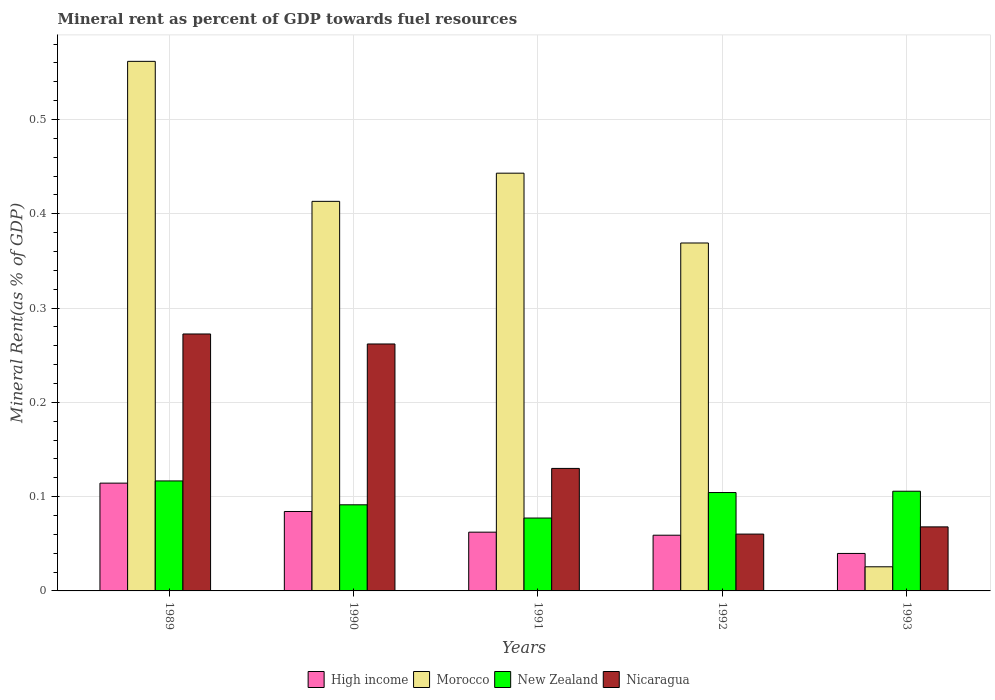How many different coloured bars are there?
Offer a terse response. 4. Are the number of bars per tick equal to the number of legend labels?
Give a very brief answer. Yes. Are the number of bars on each tick of the X-axis equal?
Make the answer very short. Yes. How many bars are there on the 2nd tick from the left?
Offer a terse response. 4. How many bars are there on the 2nd tick from the right?
Give a very brief answer. 4. In how many cases, is the number of bars for a given year not equal to the number of legend labels?
Make the answer very short. 0. What is the mineral rent in Nicaragua in 1989?
Your response must be concise. 0.27. Across all years, what is the maximum mineral rent in High income?
Make the answer very short. 0.11. Across all years, what is the minimum mineral rent in High income?
Make the answer very short. 0.04. In which year was the mineral rent in Nicaragua maximum?
Ensure brevity in your answer.  1989. What is the total mineral rent in High income in the graph?
Provide a short and direct response. 0.36. What is the difference between the mineral rent in New Zealand in 1990 and that in 1992?
Make the answer very short. -0.01. What is the difference between the mineral rent in New Zealand in 1989 and the mineral rent in High income in 1990?
Offer a terse response. 0.03. What is the average mineral rent in Morocco per year?
Keep it short and to the point. 0.36. In the year 1989, what is the difference between the mineral rent in Morocco and mineral rent in Nicaragua?
Make the answer very short. 0.29. What is the ratio of the mineral rent in Nicaragua in 1989 to that in 1991?
Provide a succinct answer. 2.1. What is the difference between the highest and the second highest mineral rent in Nicaragua?
Ensure brevity in your answer.  0.01. What is the difference between the highest and the lowest mineral rent in New Zealand?
Provide a short and direct response. 0.04. Is the sum of the mineral rent in New Zealand in 1990 and 1991 greater than the maximum mineral rent in High income across all years?
Keep it short and to the point. Yes. What does the 3rd bar from the left in 1992 represents?
Offer a very short reply. New Zealand. What does the 3rd bar from the right in 1990 represents?
Offer a very short reply. Morocco. Is it the case that in every year, the sum of the mineral rent in High income and mineral rent in Nicaragua is greater than the mineral rent in Morocco?
Ensure brevity in your answer.  No. Are all the bars in the graph horizontal?
Ensure brevity in your answer.  No. Does the graph contain grids?
Your answer should be very brief. Yes. Where does the legend appear in the graph?
Keep it short and to the point. Bottom center. How are the legend labels stacked?
Give a very brief answer. Horizontal. What is the title of the graph?
Ensure brevity in your answer.  Mineral rent as percent of GDP towards fuel resources. What is the label or title of the X-axis?
Keep it short and to the point. Years. What is the label or title of the Y-axis?
Your response must be concise. Mineral Rent(as % of GDP). What is the Mineral Rent(as % of GDP) of High income in 1989?
Keep it short and to the point. 0.11. What is the Mineral Rent(as % of GDP) in Morocco in 1989?
Ensure brevity in your answer.  0.56. What is the Mineral Rent(as % of GDP) of New Zealand in 1989?
Your answer should be very brief. 0.12. What is the Mineral Rent(as % of GDP) in Nicaragua in 1989?
Provide a succinct answer. 0.27. What is the Mineral Rent(as % of GDP) of High income in 1990?
Provide a succinct answer. 0.08. What is the Mineral Rent(as % of GDP) of Morocco in 1990?
Provide a succinct answer. 0.41. What is the Mineral Rent(as % of GDP) of New Zealand in 1990?
Give a very brief answer. 0.09. What is the Mineral Rent(as % of GDP) of Nicaragua in 1990?
Your answer should be compact. 0.26. What is the Mineral Rent(as % of GDP) in High income in 1991?
Keep it short and to the point. 0.06. What is the Mineral Rent(as % of GDP) in Morocco in 1991?
Your answer should be very brief. 0.44. What is the Mineral Rent(as % of GDP) of New Zealand in 1991?
Your response must be concise. 0.08. What is the Mineral Rent(as % of GDP) of Nicaragua in 1991?
Make the answer very short. 0.13. What is the Mineral Rent(as % of GDP) in High income in 1992?
Offer a terse response. 0.06. What is the Mineral Rent(as % of GDP) in Morocco in 1992?
Keep it short and to the point. 0.37. What is the Mineral Rent(as % of GDP) of New Zealand in 1992?
Give a very brief answer. 0.1. What is the Mineral Rent(as % of GDP) of Nicaragua in 1992?
Keep it short and to the point. 0.06. What is the Mineral Rent(as % of GDP) of High income in 1993?
Provide a succinct answer. 0.04. What is the Mineral Rent(as % of GDP) in Morocco in 1993?
Give a very brief answer. 0.03. What is the Mineral Rent(as % of GDP) of New Zealand in 1993?
Keep it short and to the point. 0.11. What is the Mineral Rent(as % of GDP) of Nicaragua in 1993?
Give a very brief answer. 0.07. Across all years, what is the maximum Mineral Rent(as % of GDP) of High income?
Ensure brevity in your answer.  0.11. Across all years, what is the maximum Mineral Rent(as % of GDP) in Morocco?
Your response must be concise. 0.56. Across all years, what is the maximum Mineral Rent(as % of GDP) of New Zealand?
Your response must be concise. 0.12. Across all years, what is the maximum Mineral Rent(as % of GDP) in Nicaragua?
Offer a terse response. 0.27. Across all years, what is the minimum Mineral Rent(as % of GDP) of High income?
Make the answer very short. 0.04. Across all years, what is the minimum Mineral Rent(as % of GDP) in Morocco?
Offer a very short reply. 0.03. Across all years, what is the minimum Mineral Rent(as % of GDP) of New Zealand?
Make the answer very short. 0.08. Across all years, what is the minimum Mineral Rent(as % of GDP) in Nicaragua?
Offer a terse response. 0.06. What is the total Mineral Rent(as % of GDP) in High income in the graph?
Your answer should be very brief. 0.36. What is the total Mineral Rent(as % of GDP) in Morocco in the graph?
Keep it short and to the point. 1.81. What is the total Mineral Rent(as % of GDP) of New Zealand in the graph?
Offer a very short reply. 0.5. What is the total Mineral Rent(as % of GDP) of Nicaragua in the graph?
Give a very brief answer. 0.79. What is the difference between the Mineral Rent(as % of GDP) of High income in 1989 and that in 1990?
Your response must be concise. 0.03. What is the difference between the Mineral Rent(as % of GDP) of Morocco in 1989 and that in 1990?
Provide a short and direct response. 0.15. What is the difference between the Mineral Rent(as % of GDP) in New Zealand in 1989 and that in 1990?
Give a very brief answer. 0.03. What is the difference between the Mineral Rent(as % of GDP) of Nicaragua in 1989 and that in 1990?
Give a very brief answer. 0.01. What is the difference between the Mineral Rent(as % of GDP) in High income in 1989 and that in 1991?
Provide a short and direct response. 0.05. What is the difference between the Mineral Rent(as % of GDP) in Morocco in 1989 and that in 1991?
Ensure brevity in your answer.  0.12. What is the difference between the Mineral Rent(as % of GDP) of New Zealand in 1989 and that in 1991?
Your response must be concise. 0.04. What is the difference between the Mineral Rent(as % of GDP) of Nicaragua in 1989 and that in 1991?
Keep it short and to the point. 0.14. What is the difference between the Mineral Rent(as % of GDP) in High income in 1989 and that in 1992?
Ensure brevity in your answer.  0.06. What is the difference between the Mineral Rent(as % of GDP) in Morocco in 1989 and that in 1992?
Your response must be concise. 0.19. What is the difference between the Mineral Rent(as % of GDP) in New Zealand in 1989 and that in 1992?
Offer a terse response. 0.01. What is the difference between the Mineral Rent(as % of GDP) in Nicaragua in 1989 and that in 1992?
Provide a short and direct response. 0.21. What is the difference between the Mineral Rent(as % of GDP) in High income in 1989 and that in 1993?
Ensure brevity in your answer.  0.07. What is the difference between the Mineral Rent(as % of GDP) in Morocco in 1989 and that in 1993?
Offer a terse response. 0.54. What is the difference between the Mineral Rent(as % of GDP) in New Zealand in 1989 and that in 1993?
Your answer should be very brief. 0.01. What is the difference between the Mineral Rent(as % of GDP) in Nicaragua in 1989 and that in 1993?
Provide a succinct answer. 0.2. What is the difference between the Mineral Rent(as % of GDP) in High income in 1990 and that in 1991?
Give a very brief answer. 0.02. What is the difference between the Mineral Rent(as % of GDP) of Morocco in 1990 and that in 1991?
Provide a succinct answer. -0.03. What is the difference between the Mineral Rent(as % of GDP) of New Zealand in 1990 and that in 1991?
Your answer should be compact. 0.01. What is the difference between the Mineral Rent(as % of GDP) of Nicaragua in 1990 and that in 1991?
Keep it short and to the point. 0.13. What is the difference between the Mineral Rent(as % of GDP) of High income in 1990 and that in 1992?
Offer a terse response. 0.03. What is the difference between the Mineral Rent(as % of GDP) in Morocco in 1990 and that in 1992?
Make the answer very short. 0.04. What is the difference between the Mineral Rent(as % of GDP) in New Zealand in 1990 and that in 1992?
Ensure brevity in your answer.  -0.01. What is the difference between the Mineral Rent(as % of GDP) of Nicaragua in 1990 and that in 1992?
Keep it short and to the point. 0.2. What is the difference between the Mineral Rent(as % of GDP) in High income in 1990 and that in 1993?
Make the answer very short. 0.04. What is the difference between the Mineral Rent(as % of GDP) in Morocco in 1990 and that in 1993?
Provide a succinct answer. 0.39. What is the difference between the Mineral Rent(as % of GDP) in New Zealand in 1990 and that in 1993?
Offer a terse response. -0.01. What is the difference between the Mineral Rent(as % of GDP) in Nicaragua in 1990 and that in 1993?
Your response must be concise. 0.19. What is the difference between the Mineral Rent(as % of GDP) of High income in 1991 and that in 1992?
Offer a terse response. 0. What is the difference between the Mineral Rent(as % of GDP) in Morocco in 1991 and that in 1992?
Give a very brief answer. 0.07. What is the difference between the Mineral Rent(as % of GDP) in New Zealand in 1991 and that in 1992?
Your response must be concise. -0.03. What is the difference between the Mineral Rent(as % of GDP) in Nicaragua in 1991 and that in 1992?
Give a very brief answer. 0.07. What is the difference between the Mineral Rent(as % of GDP) in High income in 1991 and that in 1993?
Give a very brief answer. 0.02. What is the difference between the Mineral Rent(as % of GDP) in Morocco in 1991 and that in 1993?
Ensure brevity in your answer.  0.42. What is the difference between the Mineral Rent(as % of GDP) in New Zealand in 1991 and that in 1993?
Provide a short and direct response. -0.03. What is the difference between the Mineral Rent(as % of GDP) of Nicaragua in 1991 and that in 1993?
Offer a terse response. 0.06. What is the difference between the Mineral Rent(as % of GDP) in High income in 1992 and that in 1993?
Provide a short and direct response. 0.02. What is the difference between the Mineral Rent(as % of GDP) in Morocco in 1992 and that in 1993?
Your answer should be compact. 0.34. What is the difference between the Mineral Rent(as % of GDP) in New Zealand in 1992 and that in 1993?
Give a very brief answer. -0. What is the difference between the Mineral Rent(as % of GDP) of Nicaragua in 1992 and that in 1993?
Provide a succinct answer. -0.01. What is the difference between the Mineral Rent(as % of GDP) in High income in 1989 and the Mineral Rent(as % of GDP) in Morocco in 1990?
Offer a very short reply. -0.3. What is the difference between the Mineral Rent(as % of GDP) in High income in 1989 and the Mineral Rent(as % of GDP) in New Zealand in 1990?
Your answer should be compact. 0.02. What is the difference between the Mineral Rent(as % of GDP) in High income in 1989 and the Mineral Rent(as % of GDP) in Nicaragua in 1990?
Your answer should be very brief. -0.15. What is the difference between the Mineral Rent(as % of GDP) of Morocco in 1989 and the Mineral Rent(as % of GDP) of New Zealand in 1990?
Your answer should be compact. 0.47. What is the difference between the Mineral Rent(as % of GDP) of Morocco in 1989 and the Mineral Rent(as % of GDP) of Nicaragua in 1990?
Offer a terse response. 0.3. What is the difference between the Mineral Rent(as % of GDP) of New Zealand in 1989 and the Mineral Rent(as % of GDP) of Nicaragua in 1990?
Give a very brief answer. -0.15. What is the difference between the Mineral Rent(as % of GDP) of High income in 1989 and the Mineral Rent(as % of GDP) of Morocco in 1991?
Offer a very short reply. -0.33. What is the difference between the Mineral Rent(as % of GDP) of High income in 1989 and the Mineral Rent(as % of GDP) of New Zealand in 1991?
Provide a succinct answer. 0.04. What is the difference between the Mineral Rent(as % of GDP) of High income in 1989 and the Mineral Rent(as % of GDP) of Nicaragua in 1991?
Offer a very short reply. -0.02. What is the difference between the Mineral Rent(as % of GDP) in Morocco in 1989 and the Mineral Rent(as % of GDP) in New Zealand in 1991?
Offer a terse response. 0.48. What is the difference between the Mineral Rent(as % of GDP) in Morocco in 1989 and the Mineral Rent(as % of GDP) in Nicaragua in 1991?
Make the answer very short. 0.43. What is the difference between the Mineral Rent(as % of GDP) of New Zealand in 1989 and the Mineral Rent(as % of GDP) of Nicaragua in 1991?
Your answer should be compact. -0.01. What is the difference between the Mineral Rent(as % of GDP) in High income in 1989 and the Mineral Rent(as % of GDP) in Morocco in 1992?
Keep it short and to the point. -0.25. What is the difference between the Mineral Rent(as % of GDP) of High income in 1989 and the Mineral Rent(as % of GDP) of Nicaragua in 1992?
Your answer should be very brief. 0.05. What is the difference between the Mineral Rent(as % of GDP) in Morocco in 1989 and the Mineral Rent(as % of GDP) in New Zealand in 1992?
Ensure brevity in your answer.  0.46. What is the difference between the Mineral Rent(as % of GDP) in Morocco in 1989 and the Mineral Rent(as % of GDP) in Nicaragua in 1992?
Keep it short and to the point. 0.5. What is the difference between the Mineral Rent(as % of GDP) in New Zealand in 1989 and the Mineral Rent(as % of GDP) in Nicaragua in 1992?
Your answer should be very brief. 0.06. What is the difference between the Mineral Rent(as % of GDP) of High income in 1989 and the Mineral Rent(as % of GDP) of Morocco in 1993?
Provide a succinct answer. 0.09. What is the difference between the Mineral Rent(as % of GDP) of High income in 1989 and the Mineral Rent(as % of GDP) of New Zealand in 1993?
Offer a terse response. 0.01. What is the difference between the Mineral Rent(as % of GDP) in High income in 1989 and the Mineral Rent(as % of GDP) in Nicaragua in 1993?
Your answer should be very brief. 0.05. What is the difference between the Mineral Rent(as % of GDP) in Morocco in 1989 and the Mineral Rent(as % of GDP) in New Zealand in 1993?
Ensure brevity in your answer.  0.46. What is the difference between the Mineral Rent(as % of GDP) of Morocco in 1989 and the Mineral Rent(as % of GDP) of Nicaragua in 1993?
Your response must be concise. 0.49. What is the difference between the Mineral Rent(as % of GDP) in New Zealand in 1989 and the Mineral Rent(as % of GDP) in Nicaragua in 1993?
Provide a succinct answer. 0.05. What is the difference between the Mineral Rent(as % of GDP) of High income in 1990 and the Mineral Rent(as % of GDP) of Morocco in 1991?
Your answer should be compact. -0.36. What is the difference between the Mineral Rent(as % of GDP) of High income in 1990 and the Mineral Rent(as % of GDP) of New Zealand in 1991?
Offer a very short reply. 0.01. What is the difference between the Mineral Rent(as % of GDP) in High income in 1990 and the Mineral Rent(as % of GDP) in Nicaragua in 1991?
Ensure brevity in your answer.  -0.05. What is the difference between the Mineral Rent(as % of GDP) in Morocco in 1990 and the Mineral Rent(as % of GDP) in New Zealand in 1991?
Make the answer very short. 0.34. What is the difference between the Mineral Rent(as % of GDP) in Morocco in 1990 and the Mineral Rent(as % of GDP) in Nicaragua in 1991?
Make the answer very short. 0.28. What is the difference between the Mineral Rent(as % of GDP) of New Zealand in 1990 and the Mineral Rent(as % of GDP) of Nicaragua in 1991?
Offer a very short reply. -0.04. What is the difference between the Mineral Rent(as % of GDP) of High income in 1990 and the Mineral Rent(as % of GDP) of Morocco in 1992?
Give a very brief answer. -0.28. What is the difference between the Mineral Rent(as % of GDP) in High income in 1990 and the Mineral Rent(as % of GDP) in New Zealand in 1992?
Provide a succinct answer. -0.02. What is the difference between the Mineral Rent(as % of GDP) of High income in 1990 and the Mineral Rent(as % of GDP) of Nicaragua in 1992?
Give a very brief answer. 0.02. What is the difference between the Mineral Rent(as % of GDP) of Morocco in 1990 and the Mineral Rent(as % of GDP) of New Zealand in 1992?
Offer a very short reply. 0.31. What is the difference between the Mineral Rent(as % of GDP) of Morocco in 1990 and the Mineral Rent(as % of GDP) of Nicaragua in 1992?
Make the answer very short. 0.35. What is the difference between the Mineral Rent(as % of GDP) in New Zealand in 1990 and the Mineral Rent(as % of GDP) in Nicaragua in 1992?
Offer a terse response. 0.03. What is the difference between the Mineral Rent(as % of GDP) in High income in 1990 and the Mineral Rent(as % of GDP) in Morocco in 1993?
Provide a short and direct response. 0.06. What is the difference between the Mineral Rent(as % of GDP) in High income in 1990 and the Mineral Rent(as % of GDP) in New Zealand in 1993?
Keep it short and to the point. -0.02. What is the difference between the Mineral Rent(as % of GDP) in High income in 1990 and the Mineral Rent(as % of GDP) in Nicaragua in 1993?
Offer a very short reply. 0.02. What is the difference between the Mineral Rent(as % of GDP) of Morocco in 1990 and the Mineral Rent(as % of GDP) of New Zealand in 1993?
Your answer should be compact. 0.31. What is the difference between the Mineral Rent(as % of GDP) of Morocco in 1990 and the Mineral Rent(as % of GDP) of Nicaragua in 1993?
Give a very brief answer. 0.35. What is the difference between the Mineral Rent(as % of GDP) in New Zealand in 1990 and the Mineral Rent(as % of GDP) in Nicaragua in 1993?
Your answer should be very brief. 0.02. What is the difference between the Mineral Rent(as % of GDP) in High income in 1991 and the Mineral Rent(as % of GDP) in Morocco in 1992?
Provide a succinct answer. -0.31. What is the difference between the Mineral Rent(as % of GDP) of High income in 1991 and the Mineral Rent(as % of GDP) of New Zealand in 1992?
Give a very brief answer. -0.04. What is the difference between the Mineral Rent(as % of GDP) in High income in 1991 and the Mineral Rent(as % of GDP) in Nicaragua in 1992?
Your answer should be very brief. 0. What is the difference between the Mineral Rent(as % of GDP) in Morocco in 1991 and the Mineral Rent(as % of GDP) in New Zealand in 1992?
Offer a very short reply. 0.34. What is the difference between the Mineral Rent(as % of GDP) of Morocco in 1991 and the Mineral Rent(as % of GDP) of Nicaragua in 1992?
Offer a terse response. 0.38. What is the difference between the Mineral Rent(as % of GDP) in New Zealand in 1991 and the Mineral Rent(as % of GDP) in Nicaragua in 1992?
Ensure brevity in your answer.  0.02. What is the difference between the Mineral Rent(as % of GDP) in High income in 1991 and the Mineral Rent(as % of GDP) in Morocco in 1993?
Offer a very short reply. 0.04. What is the difference between the Mineral Rent(as % of GDP) of High income in 1991 and the Mineral Rent(as % of GDP) of New Zealand in 1993?
Provide a succinct answer. -0.04. What is the difference between the Mineral Rent(as % of GDP) in High income in 1991 and the Mineral Rent(as % of GDP) in Nicaragua in 1993?
Your response must be concise. -0.01. What is the difference between the Mineral Rent(as % of GDP) in Morocco in 1991 and the Mineral Rent(as % of GDP) in New Zealand in 1993?
Your response must be concise. 0.34. What is the difference between the Mineral Rent(as % of GDP) in Morocco in 1991 and the Mineral Rent(as % of GDP) in Nicaragua in 1993?
Offer a terse response. 0.38. What is the difference between the Mineral Rent(as % of GDP) in New Zealand in 1991 and the Mineral Rent(as % of GDP) in Nicaragua in 1993?
Provide a short and direct response. 0.01. What is the difference between the Mineral Rent(as % of GDP) of High income in 1992 and the Mineral Rent(as % of GDP) of Morocco in 1993?
Offer a very short reply. 0.03. What is the difference between the Mineral Rent(as % of GDP) of High income in 1992 and the Mineral Rent(as % of GDP) of New Zealand in 1993?
Your response must be concise. -0.05. What is the difference between the Mineral Rent(as % of GDP) of High income in 1992 and the Mineral Rent(as % of GDP) of Nicaragua in 1993?
Keep it short and to the point. -0.01. What is the difference between the Mineral Rent(as % of GDP) in Morocco in 1992 and the Mineral Rent(as % of GDP) in New Zealand in 1993?
Provide a succinct answer. 0.26. What is the difference between the Mineral Rent(as % of GDP) of Morocco in 1992 and the Mineral Rent(as % of GDP) of Nicaragua in 1993?
Make the answer very short. 0.3. What is the difference between the Mineral Rent(as % of GDP) of New Zealand in 1992 and the Mineral Rent(as % of GDP) of Nicaragua in 1993?
Keep it short and to the point. 0.04. What is the average Mineral Rent(as % of GDP) of High income per year?
Your answer should be very brief. 0.07. What is the average Mineral Rent(as % of GDP) in Morocco per year?
Offer a very short reply. 0.36. What is the average Mineral Rent(as % of GDP) of New Zealand per year?
Keep it short and to the point. 0.1. What is the average Mineral Rent(as % of GDP) of Nicaragua per year?
Keep it short and to the point. 0.16. In the year 1989, what is the difference between the Mineral Rent(as % of GDP) in High income and Mineral Rent(as % of GDP) in Morocco?
Ensure brevity in your answer.  -0.45. In the year 1989, what is the difference between the Mineral Rent(as % of GDP) of High income and Mineral Rent(as % of GDP) of New Zealand?
Your answer should be compact. -0. In the year 1989, what is the difference between the Mineral Rent(as % of GDP) in High income and Mineral Rent(as % of GDP) in Nicaragua?
Give a very brief answer. -0.16. In the year 1989, what is the difference between the Mineral Rent(as % of GDP) in Morocco and Mineral Rent(as % of GDP) in New Zealand?
Your response must be concise. 0.45. In the year 1989, what is the difference between the Mineral Rent(as % of GDP) of Morocco and Mineral Rent(as % of GDP) of Nicaragua?
Your answer should be very brief. 0.29. In the year 1989, what is the difference between the Mineral Rent(as % of GDP) of New Zealand and Mineral Rent(as % of GDP) of Nicaragua?
Offer a very short reply. -0.16. In the year 1990, what is the difference between the Mineral Rent(as % of GDP) in High income and Mineral Rent(as % of GDP) in Morocco?
Provide a succinct answer. -0.33. In the year 1990, what is the difference between the Mineral Rent(as % of GDP) in High income and Mineral Rent(as % of GDP) in New Zealand?
Keep it short and to the point. -0.01. In the year 1990, what is the difference between the Mineral Rent(as % of GDP) of High income and Mineral Rent(as % of GDP) of Nicaragua?
Provide a succinct answer. -0.18. In the year 1990, what is the difference between the Mineral Rent(as % of GDP) in Morocco and Mineral Rent(as % of GDP) in New Zealand?
Ensure brevity in your answer.  0.32. In the year 1990, what is the difference between the Mineral Rent(as % of GDP) of Morocco and Mineral Rent(as % of GDP) of Nicaragua?
Provide a short and direct response. 0.15. In the year 1990, what is the difference between the Mineral Rent(as % of GDP) in New Zealand and Mineral Rent(as % of GDP) in Nicaragua?
Provide a succinct answer. -0.17. In the year 1991, what is the difference between the Mineral Rent(as % of GDP) in High income and Mineral Rent(as % of GDP) in Morocco?
Provide a succinct answer. -0.38. In the year 1991, what is the difference between the Mineral Rent(as % of GDP) of High income and Mineral Rent(as % of GDP) of New Zealand?
Ensure brevity in your answer.  -0.01. In the year 1991, what is the difference between the Mineral Rent(as % of GDP) in High income and Mineral Rent(as % of GDP) in Nicaragua?
Your answer should be very brief. -0.07. In the year 1991, what is the difference between the Mineral Rent(as % of GDP) in Morocco and Mineral Rent(as % of GDP) in New Zealand?
Give a very brief answer. 0.37. In the year 1991, what is the difference between the Mineral Rent(as % of GDP) of Morocco and Mineral Rent(as % of GDP) of Nicaragua?
Give a very brief answer. 0.31. In the year 1991, what is the difference between the Mineral Rent(as % of GDP) of New Zealand and Mineral Rent(as % of GDP) of Nicaragua?
Offer a very short reply. -0.05. In the year 1992, what is the difference between the Mineral Rent(as % of GDP) in High income and Mineral Rent(as % of GDP) in Morocco?
Your answer should be very brief. -0.31. In the year 1992, what is the difference between the Mineral Rent(as % of GDP) of High income and Mineral Rent(as % of GDP) of New Zealand?
Keep it short and to the point. -0.05. In the year 1992, what is the difference between the Mineral Rent(as % of GDP) in High income and Mineral Rent(as % of GDP) in Nicaragua?
Keep it short and to the point. -0. In the year 1992, what is the difference between the Mineral Rent(as % of GDP) of Morocco and Mineral Rent(as % of GDP) of New Zealand?
Ensure brevity in your answer.  0.26. In the year 1992, what is the difference between the Mineral Rent(as % of GDP) in Morocco and Mineral Rent(as % of GDP) in Nicaragua?
Ensure brevity in your answer.  0.31. In the year 1992, what is the difference between the Mineral Rent(as % of GDP) of New Zealand and Mineral Rent(as % of GDP) of Nicaragua?
Provide a short and direct response. 0.04. In the year 1993, what is the difference between the Mineral Rent(as % of GDP) of High income and Mineral Rent(as % of GDP) of Morocco?
Ensure brevity in your answer.  0.01. In the year 1993, what is the difference between the Mineral Rent(as % of GDP) of High income and Mineral Rent(as % of GDP) of New Zealand?
Your answer should be very brief. -0.07. In the year 1993, what is the difference between the Mineral Rent(as % of GDP) in High income and Mineral Rent(as % of GDP) in Nicaragua?
Offer a very short reply. -0.03. In the year 1993, what is the difference between the Mineral Rent(as % of GDP) of Morocco and Mineral Rent(as % of GDP) of New Zealand?
Keep it short and to the point. -0.08. In the year 1993, what is the difference between the Mineral Rent(as % of GDP) of Morocco and Mineral Rent(as % of GDP) of Nicaragua?
Give a very brief answer. -0.04. In the year 1993, what is the difference between the Mineral Rent(as % of GDP) of New Zealand and Mineral Rent(as % of GDP) of Nicaragua?
Offer a very short reply. 0.04. What is the ratio of the Mineral Rent(as % of GDP) of High income in 1989 to that in 1990?
Give a very brief answer. 1.36. What is the ratio of the Mineral Rent(as % of GDP) in Morocco in 1989 to that in 1990?
Your answer should be very brief. 1.36. What is the ratio of the Mineral Rent(as % of GDP) of New Zealand in 1989 to that in 1990?
Your answer should be compact. 1.28. What is the ratio of the Mineral Rent(as % of GDP) of Nicaragua in 1989 to that in 1990?
Offer a very short reply. 1.04. What is the ratio of the Mineral Rent(as % of GDP) in High income in 1989 to that in 1991?
Offer a very short reply. 1.83. What is the ratio of the Mineral Rent(as % of GDP) of Morocco in 1989 to that in 1991?
Give a very brief answer. 1.27. What is the ratio of the Mineral Rent(as % of GDP) of New Zealand in 1989 to that in 1991?
Provide a succinct answer. 1.51. What is the ratio of the Mineral Rent(as % of GDP) of Nicaragua in 1989 to that in 1991?
Your answer should be compact. 2.1. What is the ratio of the Mineral Rent(as % of GDP) in High income in 1989 to that in 1992?
Give a very brief answer. 1.94. What is the ratio of the Mineral Rent(as % of GDP) of Morocco in 1989 to that in 1992?
Ensure brevity in your answer.  1.52. What is the ratio of the Mineral Rent(as % of GDP) of New Zealand in 1989 to that in 1992?
Provide a short and direct response. 1.12. What is the ratio of the Mineral Rent(as % of GDP) in Nicaragua in 1989 to that in 1992?
Provide a short and direct response. 4.52. What is the ratio of the Mineral Rent(as % of GDP) of High income in 1989 to that in 1993?
Offer a terse response. 2.88. What is the ratio of the Mineral Rent(as % of GDP) of Morocco in 1989 to that in 1993?
Provide a short and direct response. 21.95. What is the ratio of the Mineral Rent(as % of GDP) in New Zealand in 1989 to that in 1993?
Your response must be concise. 1.1. What is the ratio of the Mineral Rent(as % of GDP) of Nicaragua in 1989 to that in 1993?
Ensure brevity in your answer.  4.01. What is the ratio of the Mineral Rent(as % of GDP) in High income in 1990 to that in 1991?
Provide a short and direct response. 1.35. What is the ratio of the Mineral Rent(as % of GDP) in Morocco in 1990 to that in 1991?
Offer a very short reply. 0.93. What is the ratio of the Mineral Rent(as % of GDP) in New Zealand in 1990 to that in 1991?
Your answer should be compact. 1.18. What is the ratio of the Mineral Rent(as % of GDP) in Nicaragua in 1990 to that in 1991?
Provide a short and direct response. 2.02. What is the ratio of the Mineral Rent(as % of GDP) of High income in 1990 to that in 1992?
Your answer should be compact. 1.43. What is the ratio of the Mineral Rent(as % of GDP) in Morocco in 1990 to that in 1992?
Offer a terse response. 1.12. What is the ratio of the Mineral Rent(as % of GDP) in New Zealand in 1990 to that in 1992?
Give a very brief answer. 0.88. What is the ratio of the Mineral Rent(as % of GDP) of Nicaragua in 1990 to that in 1992?
Your answer should be compact. 4.34. What is the ratio of the Mineral Rent(as % of GDP) of High income in 1990 to that in 1993?
Provide a succinct answer. 2.12. What is the ratio of the Mineral Rent(as % of GDP) in Morocco in 1990 to that in 1993?
Give a very brief answer. 16.14. What is the ratio of the Mineral Rent(as % of GDP) of New Zealand in 1990 to that in 1993?
Keep it short and to the point. 0.86. What is the ratio of the Mineral Rent(as % of GDP) of Nicaragua in 1990 to that in 1993?
Provide a succinct answer. 3.86. What is the ratio of the Mineral Rent(as % of GDP) of High income in 1991 to that in 1992?
Make the answer very short. 1.05. What is the ratio of the Mineral Rent(as % of GDP) of Morocco in 1991 to that in 1992?
Keep it short and to the point. 1.2. What is the ratio of the Mineral Rent(as % of GDP) of New Zealand in 1991 to that in 1992?
Provide a succinct answer. 0.74. What is the ratio of the Mineral Rent(as % of GDP) of Nicaragua in 1991 to that in 1992?
Provide a short and direct response. 2.16. What is the ratio of the Mineral Rent(as % of GDP) in High income in 1991 to that in 1993?
Offer a very short reply. 1.57. What is the ratio of the Mineral Rent(as % of GDP) in Morocco in 1991 to that in 1993?
Offer a terse response. 17.31. What is the ratio of the Mineral Rent(as % of GDP) of New Zealand in 1991 to that in 1993?
Provide a succinct answer. 0.73. What is the ratio of the Mineral Rent(as % of GDP) of Nicaragua in 1991 to that in 1993?
Your response must be concise. 1.91. What is the ratio of the Mineral Rent(as % of GDP) in High income in 1992 to that in 1993?
Make the answer very short. 1.49. What is the ratio of the Mineral Rent(as % of GDP) of Morocco in 1992 to that in 1993?
Give a very brief answer. 14.42. What is the ratio of the Mineral Rent(as % of GDP) in New Zealand in 1992 to that in 1993?
Offer a very short reply. 0.99. What is the ratio of the Mineral Rent(as % of GDP) in Nicaragua in 1992 to that in 1993?
Your answer should be very brief. 0.89. What is the difference between the highest and the second highest Mineral Rent(as % of GDP) in High income?
Provide a succinct answer. 0.03. What is the difference between the highest and the second highest Mineral Rent(as % of GDP) in Morocco?
Provide a short and direct response. 0.12. What is the difference between the highest and the second highest Mineral Rent(as % of GDP) of New Zealand?
Your answer should be compact. 0.01. What is the difference between the highest and the second highest Mineral Rent(as % of GDP) of Nicaragua?
Provide a short and direct response. 0.01. What is the difference between the highest and the lowest Mineral Rent(as % of GDP) in High income?
Your answer should be very brief. 0.07. What is the difference between the highest and the lowest Mineral Rent(as % of GDP) of Morocco?
Provide a short and direct response. 0.54. What is the difference between the highest and the lowest Mineral Rent(as % of GDP) of New Zealand?
Your response must be concise. 0.04. What is the difference between the highest and the lowest Mineral Rent(as % of GDP) in Nicaragua?
Your answer should be compact. 0.21. 